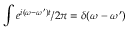Convert formula to latex. <formula><loc_0><loc_0><loc_500><loc_500>\int e ^ { i ( \omega - \omega ^ { \prime } ) t } / 2 \pi = \delta ( \omega - \omega ^ { \prime } )</formula> 